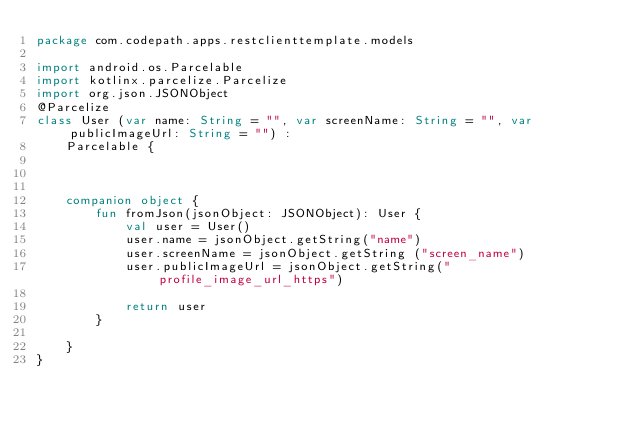Convert code to text. <code><loc_0><loc_0><loc_500><loc_500><_Kotlin_>package com.codepath.apps.restclienttemplate.models

import android.os.Parcelable
import kotlinx.parcelize.Parcelize
import org.json.JSONObject
@Parcelize
class User (var name: String = "", var screenName: String = "", var publicImageUrl: String = "") :
    Parcelable {



    companion object {
        fun fromJson(jsonObject: JSONObject): User {
            val user = User()
            user.name = jsonObject.getString("name")
            user.screenName = jsonObject.getString ("screen_name")
            user.publicImageUrl = jsonObject.getString("profile_image_url_https")

            return user
        }

    }
}</code> 